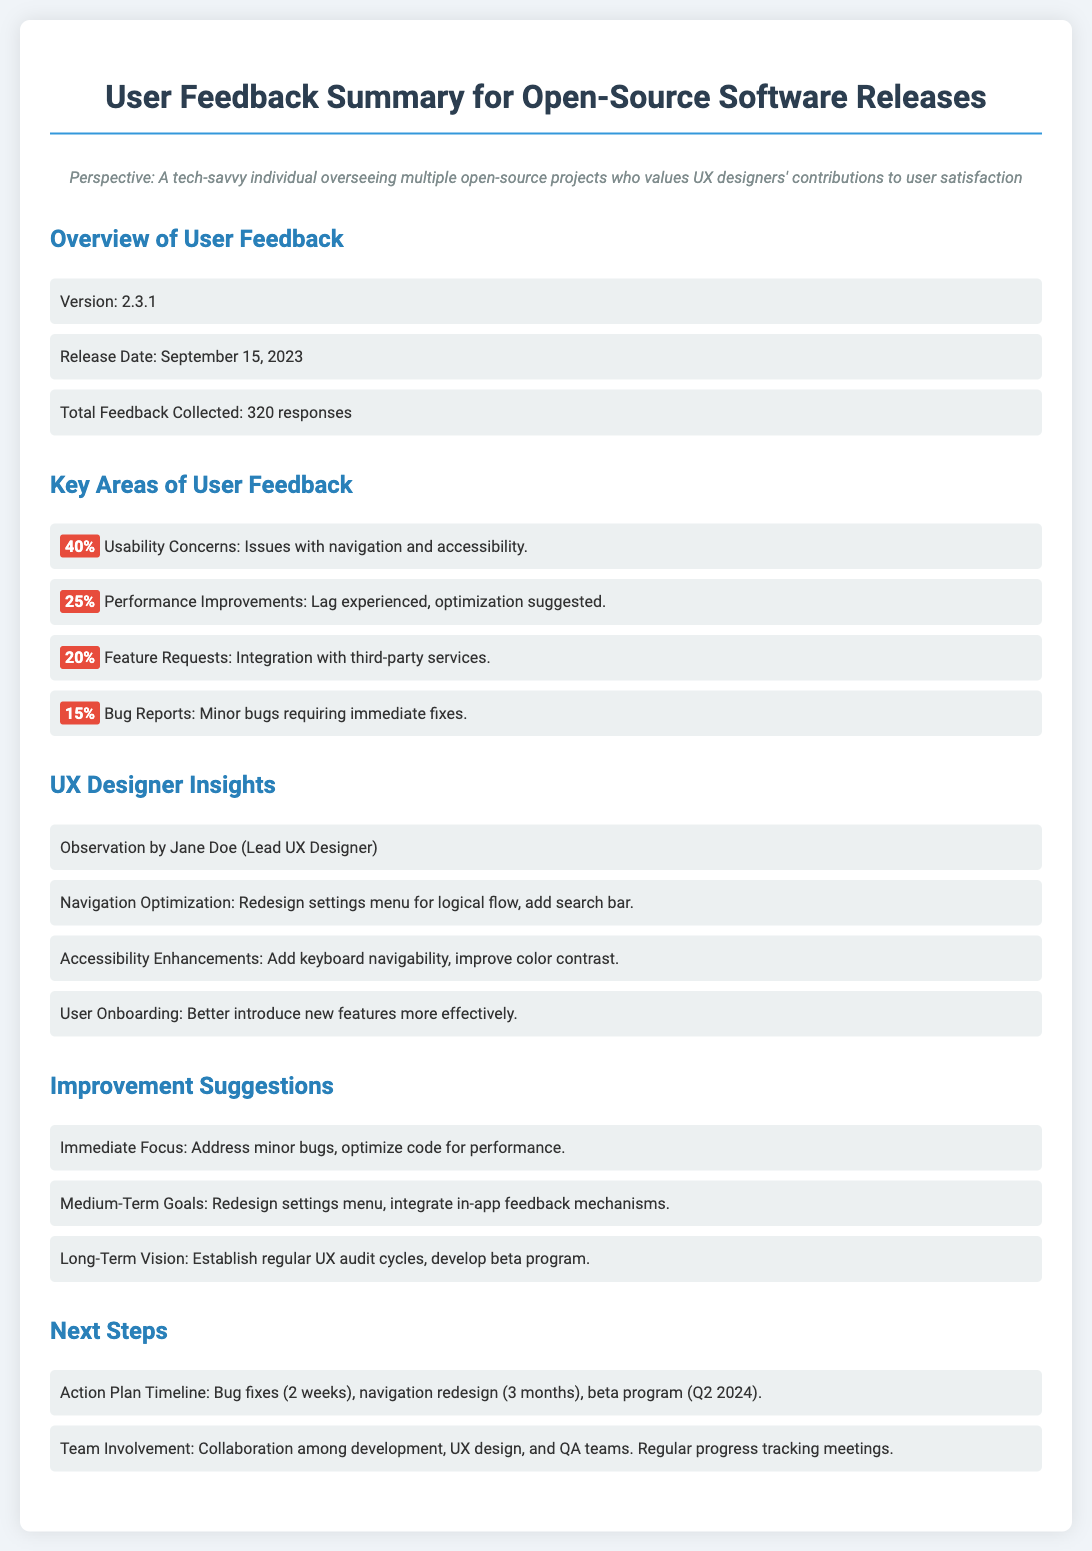What is the version of the software? The version of the software is stated in the overview section of the document.
Answer: 2.3.1 When was the release date? The release date is specified in the overview section.
Answer: September 15, 2023 How many total feedback responses were collected? The total feedback count is listed as part of the overview.
Answer: 320 responses What percentage of users reported usability concerns? The percentage of usability concerns can be found in the key areas of user feedback.
Answer: 40% Who is the lead UX designer mentioned? The lead UX designer's name is provided under the UX designer insights section.
Answer: Jane Doe What is the immediate focus for improvement suggested? The immediate focus for improvement is indicated in the improvement suggestions section.
Answer: Address minor bugs What is the timeline for bug fixes? The action plan timeline for bug fixes is detailed in the next steps section.
Answer: 2 weeks What is one medium-term goal for improvement? The medium-term goals are outlined in the improvement suggestions section.
Answer: Redesign settings menu How often will UX audits be established? The long-term vision mentions the frequency of establishing UX audits.
Answer: Regularly 